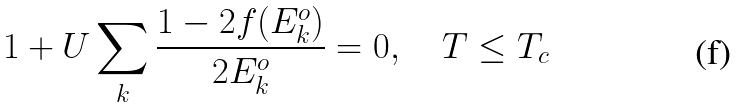Convert formula to latex. <formula><loc_0><loc_0><loc_500><loc_500>1 + U \sum _ { k } \frac { 1 - 2 f ( E _ { k } ^ { o } ) } { 2 E _ { k } ^ { o } } = 0 , \quad T \leq T _ { c }</formula> 